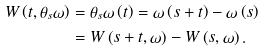Convert formula to latex. <formula><loc_0><loc_0><loc_500><loc_500>W \left ( t , \theta _ { s } \omega \right ) & = \theta _ { s } \omega \left ( t \right ) = \omega \left ( s + t \right ) - \omega \left ( s \right ) \\ & = W \left ( s + t , \omega \right ) - W \left ( s , \omega \right ) .</formula> 